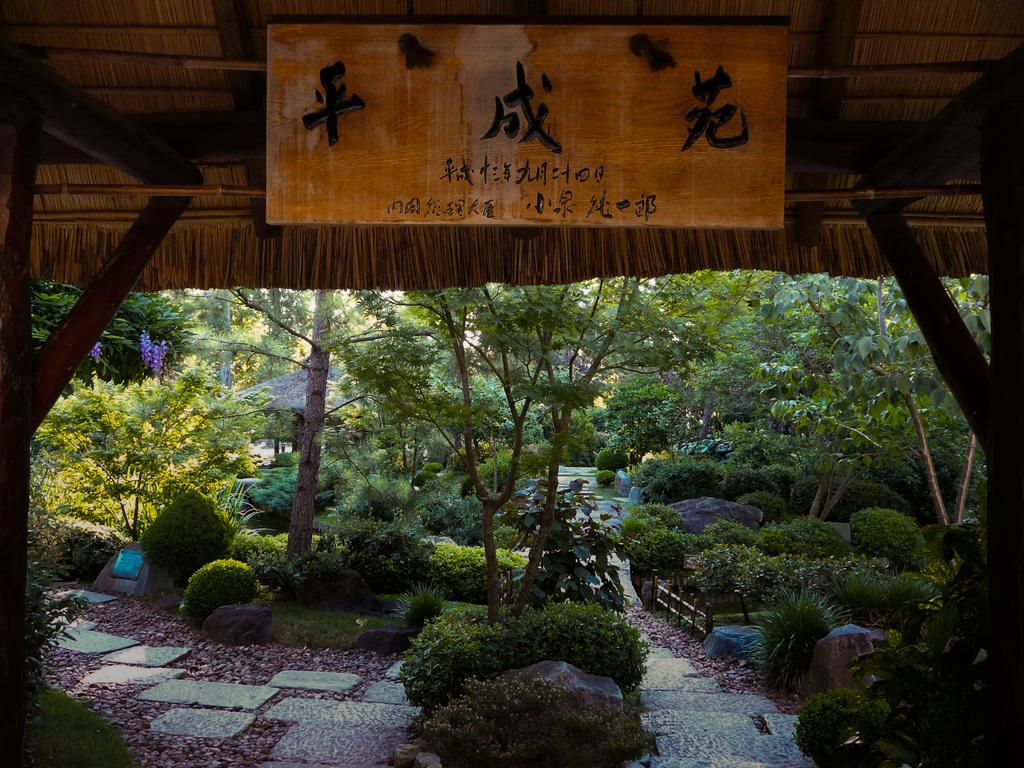What type of structure can be seen in the image? There is a shed in the image. What is located near the shed? There is a wooden board with symbols in the image. What type of natural elements are present in the image? There are trees, plants, and flowers in the image. Are there any architectural features in the image? Yes, there are stairs and a fence in the image. What is the smallest object visible in the image? There is a stone in the image. What type of gate can be seen in the image? There is no gate present in the image. What type of root system can be observed for the plants in the image? There is no root system visible in the image, as only the above-ground parts of the plants are shown. 